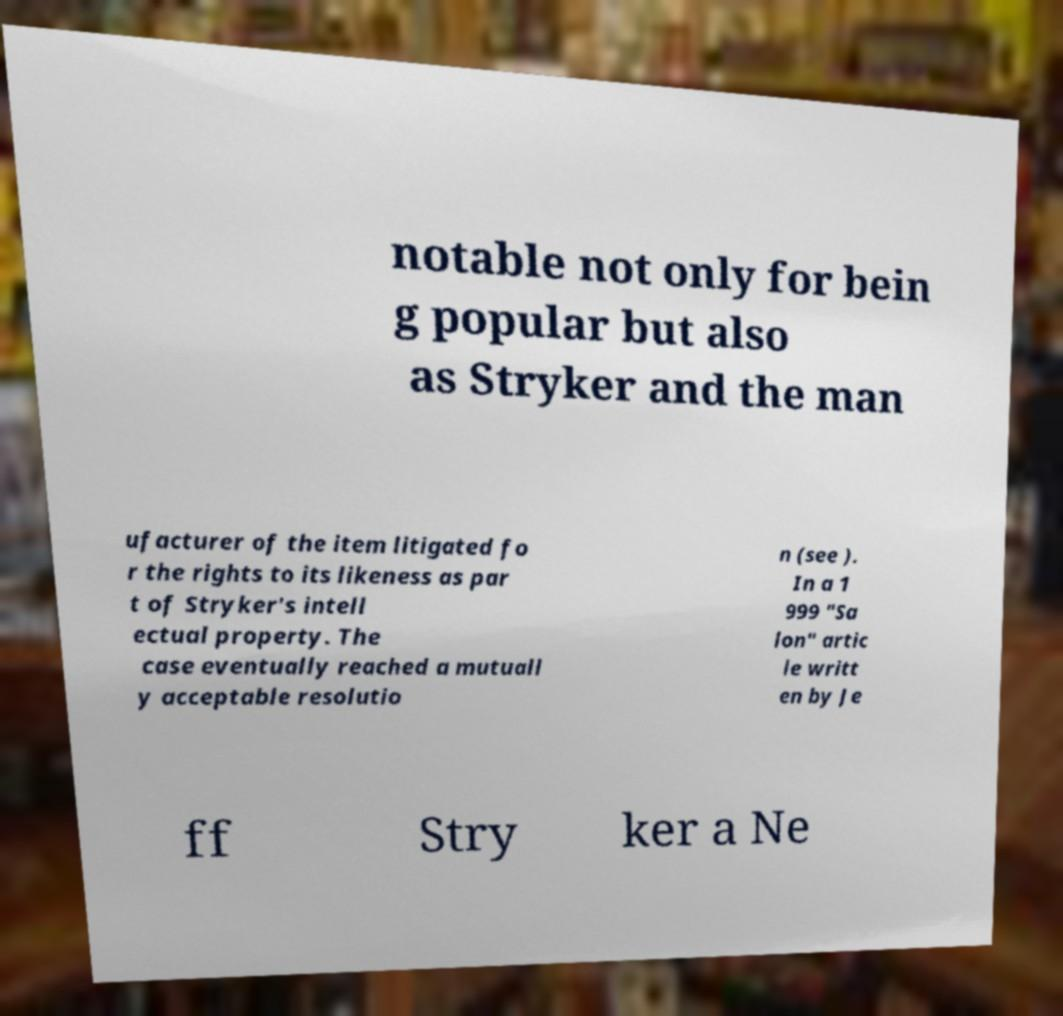Can you read and provide the text displayed in the image?This photo seems to have some interesting text. Can you extract and type it out for me? notable not only for bein g popular but also as Stryker and the man ufacturer of the item litigated fo r the rights to its likeness as par t of Stryker's intell ectual property. The case eventually reached a mutuall y acceptable resolutio n (see ). In a 1 999 "Sa lon" artic le writt en by Je ff Stry ker a Ne 